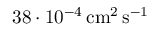<formula> <loc_0><loc_0><loc_500><loc_500>3 8 \cdot 1 0 ^ { - 4 } \, c m ^ { 2 } \, s ^ { - 1 }</formula> 